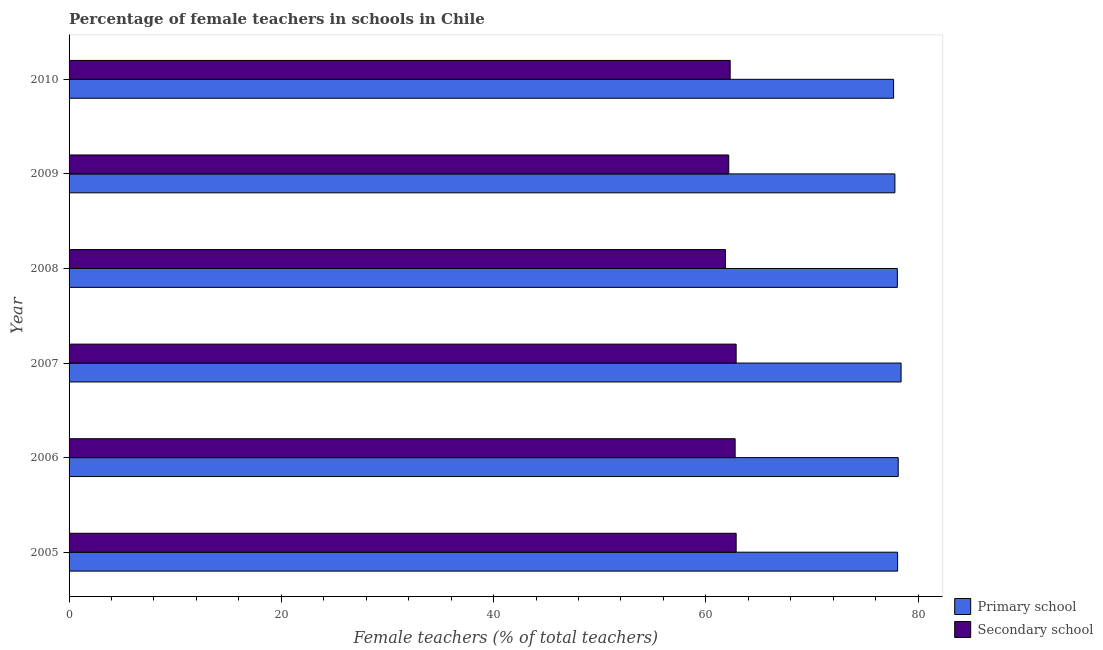How many different coloured bars are there?
Offer a terse response. 2. In how many cases, is the number of bars for a given year not equal to the number of legend labels?
Your answer should be compact. 0. What is the percentage of female teachers in primary schools in 2006?
Ensure brevity in your answer.  78.13. Across all years, what is the maximum percentage of female teachers in primary schools?
Offer a very short reply. 78.4. Across all years, what is the minimum percentage of female teachers in primary schools?
Give a very brief answer. 77.69. What is the total percentage of female teachers in secondary schools in the graph?
Offer a very short reply. 374.78. What is the difference between the percentage of female teachers in secondary schools in 2007 and that in 2009?
Keep it short and to the point. 0.7. What is the difference between the percentage of female teachers in primary schools in 2009 and the percentage of female teachers in secondary schools in 2006?
Offer a terse response. 15.05. What is the average percentage of female teachers in secondary schools per year?
Keep it short and to the point. 62.46. In the year 2007, what is the difference between the percentage of female teachers in secondary schools and percentage of female teachers in primary schools?
Make the answer very short. -15.54. In how many years, is the percentage of female teachers in secondary schools greater than 4 %?
Offer a very short reply. 6. Is the percentage of female teachers in secondary schools in 2005 less than that in 2009?
Provide a succinct answer. No. What is the difference between the highest and the second highest percentage of female teachers in primary schools?
Your answer should be compact. 0.27. What is the difference between the highest and the lowest percentage of female teachers in primary schools?
Ensure brevity in your answer.  0.71. In how many years, is the percentage of female teachers in primary schools greater than the average percentage of female teachers in primary schools taken over all years?
Offer a terse response. 4. Is the sum of the percentage of female teachers in secondary schools in 2005 and 2010 greater than the maximum percentage of female teachers in primary schools across all years?
Your response must be concise. Yes. What does the 1st bar from the top in 2010 represents?
Ensure brevity in your answer.  Secondary school. What does the 1st bar from the bottom in 2010 represents?
Your answer should be very brief. Primary school. Are all the bars in the graph horizontal?
Offer a terse response. Yes. Are the values on the major ticks of X-axis written in scientific E-notation?
Your answer should be very brief. No. Does the graph contain any zero values?
Keep it short and to the point. No. Where does the legend appear in the graph?
Provide a succinct answer. Bottom right. How many legend labels are there?
Your answer should be very brief. 2. How are the legend labels stacked?
Offer a terse response. Vertical. What is the title of the graph?
Your response must be concise. Percentage of female teachers in schools in Chile. Does "Primary school" appear as one of the legend labels in the graph?
Your answer should be very brief. Yes. What is the label or title of the X-axis?
Provide a succinct answer. Female teachers (% of total teachers). What is the label or title of the Y-axis?
Provide a short and direct response. Year. What is the Female teachers (% of total teachers) in Primary school in 2005?
Make the answer very short. 78.07. What is the Female teachers (% of total teachers) of Secondary school in 2005?
Your answer should be very brief. 62.86. What is the Female teachers (% of total teachers) in Primary school in 2006?
Give a very brief answer. 78.13. What is the Female teachers (% of total teachers) in Secondary school in 2006?
Provide a short and direct response. 62.76. What is the Female teachers (% of total teachers) of Primary school in 2007?
Provide a succinct answer. 78.4. What is the Female teachers (% of total teachers) in Secondary school in 2007?
Offer a very short reply. 62.86. What is the Female teachers (% of total teachers) in Primary school in 2008?
Provide a short and direct response. 78.05. What is the Female teachers (% of total teachers) in Secondary school in 2008?
Provide a short and direct response. 61.85. What is the Female teachers (% of total teachers) in Primary school in 2009?
Make the answer very short. 77.82. What is the Female teachers (% of total teachers) of Secondary school in 2009?
Your answer should be compact. 62.16. What is the Female teachers (% of total teachers) in Primary school in 2010?
Your answer should be compact. 77.69. What is the Female teachers (% of total teachers) of Secondary school in 2010?
Offer a terse response. 62.29. Across all years, what is the maximum Female teachers (% of total teachers) in Primary school?
Offer a very short reply. 78.4. Across all years, what is the maximum Female teachers (% of total teachers) in Secondary school?
Offer a terse response. 62.86. Across all years, what is the minimum Female teachers (% of total teachers) of Primary school?
Give a very brief answer. 77.69. Across all years, what is the minimum Female teachers (% of total teachers) in Secondary school?
Your answer should be very brief. 61.85. What is the total Female teachers (% of total teachers) of Primary school in the graph?
Give a very brief answer. 468.15. What is the total Female teachers (% of total teachers) in Secondary school in the graph?
Your response must be concise. 374.78. What is the difference between the Female teachers (% of total teachers) in Primary school in 2005 and that in 2006?
Provide a short and direct response. -0.06. What is the difference between the Female teachers (% of total teachers) of Secondary school in 2005 and that in 2006?
Provide a short and direct response. 0.1. What is the difference between the Female teachers (% of total teachers) in Primary school in 2005 and that in 2007?
Your answer should be very brief. -0.33. What is the difference between the Female teachers (% of total teachers) of Secondary school in 2005 and that in 2007?
Give a very brief answer. 0. What is the difference between the Female teachers (% of total teachers) in Primary school in 2005 and that in 2008?
Offer a very short reply. 0.02. What is the difference between the Female teachers (% of total teachers) of Secondary school in 2005 and that in 2008?
Your response must be concise. 1.01. What is the difference between the Female teachers (% of total teachers) of Primary school in 2005 and that in 2009?
Give a very brief answer. 0.25. What is the difference between the Female teachers (% of total teachers) in Secondary school in 2005 and that in 2009?
Your answer should be compact. 0.7. What is the difference between the Female teachers (% of total teachers) of Primary school in 2005 and that in 2010?
Give a very brief answer. 0.38. What is the difference between the Female teachers (% of total teachers) of Secondary school in 2005 and that in 2010?
Make the answer very short. 0.56. What is the difference between the Female teachers (% of total teachers) in Primary school in 2006 and that in 2007?
Provide a succinct answer. -0.27. What is the difference between the Female teachers (% of total teachers) of Secondary school in 2006 and that in 2007?
Your answer should be very brief. -0.09. What is the difference between the Female teachers (% of total teachers) in Primary school in 2006 and that in 2008?
Your response must be concise. 0.08. What is the difference between the Female teachers (% of total teachers) in Secondary school in 2006 and that in 2008?
Ensure brevity in your answer.  0.91. What is the difference between the Female teachers (% of total teachers) of Primary school in 2006 and that in 2009?
Offer a terse response. 0.31. What is the difference between the Female teachers (% of total teachers) of Secondary school in 2006 and that in 2009?
Make the answer very short. 0.6. What is the difference between the Female teachers (% of total teachers) in Primary school in 2006 and that in 2010?
Make the answer very short. 0.44. What is the difference between the Female teachers (% of total teachers) in Secondary school in 2006 and that in 2010?
Your answer should be compact. 0.47. What is the difference between the Female teachers (% of total teachers) in Primary school in 2007 and that in 2008?
Provide a succinct answer. 0.35. What is the difference between the Female teachers (% of total teachers) of Primary school in 2007 and that in 2009?
Ensure brevity in your answer.  0.58. What is the difference between the Female teachers (% of total teachers) in Secondary school in 2007 and that in 2009?
Your answer should be very brief. 0.7. What is the difference between the Female teachers (% of total teachers) in Primary school in 2007 and that in 2010?
Provide a succinct answer. 0.71. What is the difference between the Female teachers (% of total teachers) of Secondary school in 2007 and that in 2010?
Your answer should be compact. 0.56. What is the difference between the Female teachers (% of total teachers) of Primary school in 2008 and that in 2009?
Your response must be concise. 0.23. What is the difference between the Female teachers (% of total teachers) of Secondary school in 2008 and that in 2009?
Your answer should be compact. -0.31. What is the difference between the Female teachers (% of total teachers) of Primary school in 2008 and that in 2010?
Make the answer very short. 0.35. What is the difference between the Female teachers (% of total teachers) of Secondary school in 2008 and that in 2010?
Provide a succinct answer. -0.44. What is the difference between the Female teachers (% of total teachers) in Primary school in 2009 and that in 2010?
Offer a very short reply. 0.12. What is the difference between the Female teachers (% of total teachers) in Secondary school in 2009 and that in 2010?
Provide a short and direct response. -0.13. What is the difference between the Female teachers (% of total teachers) in Primary school in 2005 and the Female teachers (% of total teachers) in Secondary school in 2006?
Provide a succinct answer. 15.31. What is the difference between the Female teachers (% of total teachers) in Primary school in 2005 and the Female teachers (% of total teachers) in Secondary school in 2007?
Keep it short and to the point. 15.21. What is the difference between the Female teachers (% of total teachers) in Primary school in 2005 and the Female teachers (% of total teachers) in Secondary school in 2008?
Keep it short and to the point. 16.22. What is the difference between the Female teachers (% of total teachers) of Primary school in 2005 and the Female teachers (% of total teachers) of Secondary school in 2009?
Provide a succinct answer. 15.91. What is the difference between the Female teachers (% of total teachers) of Primary school in 2005 and the Female teachers (% of total teachers) of Secondary school in 2010?
Make the answer very short. 15.78. What is the difference between the Female teachers (% of total teachers) of Primary school in 2006 and the Female teachers (% of total teachers) of Secondary school in 2007?
Your answer should be compact. 15.27. What is the difference between the Female teachers (% of total teachers) of Primary school in 2006 and the Female teachers (% of total teachers) of Secondary school in 2008?
Your answer should be compact. 16.28. What is the difference between the Female teachers (% of total teachers) in Primary school in 2006 and the Female teachers (% of total teachers) in Secondary school in 2009?
Offer a very short reply. 15.97. What is the difference between the Female teachers (% of total teachers) of Primary school in 2006 and the Female teachers (% of total teachers) of Secondary school in 2010?
Offer a very short reply. 15.84. What is the difference between the Female teachers (% of total teachers) of Primary school in 2007 and the Female teachers (% of total teachers) of Secondary school in 2008?
Your answer should be compact. 16.55. What is the difference between the Female teachers (% of total teachers) of Primary school in 2007 and the Female teachers (% of total teachers) of Secondary school in 2009?
Your answer should be compact. 16.24. What is the difference between the Female teachers (% of total teachers) in Primary school in 2007 and the Female teachers (% of total teachers) in Secondary school in 2010?
Offer a very short reply. 16.1. What is the difference between the Female teachers (% of total teachers) of Primary school in 2008 and the Female teachers (% of total teachers) of Secondary school in 2009?
Provide a succinct answer. 15.89. What is the difference between the Female teachers (% of total teachers) of Primary school in 2008 and the Female teachers (% of total teachers) of Secondary school in 2010?
Provide a short and direct response. 15.75. What is the difference between the Female teachers (% of total teachers) in Primary school in 2009 and the Female teachers (% of total teachers) in Secondary school in 2010?
Provide a succinct answer. 15.52. What is the average Female teachers (% of total teachers) of Primary school per year?
Offer a terse response. 78.02. What is the average Female teachers (% of total teachers) in Secondary school per year?
Give a very brief answer. 62.46. In the year 2005, what is the difference between the Female teachers (% of total teachers) in Primary school and Female teachers (% of total teachers) in Secondary school?
Your response must be concise. 15.21. In the year 2006, what is the difference between the Female teachers (% of total teachers) in Primary school and Female teachers (% of total teachers) in Secondary school?
Provide a succinct answer. 15.37. In the year 2007, what is the difference between the Female teachers (% of total teachers) of Primary school and Female teachers (% of total teachers) of Secondary school?
Your answer should be compact. 15.54. In the year 2008, what is the difference between the Female teachers (% of total teachers) in Primary school and Female teachers (% of total teachers) in Secondary school?
Keep it short and to the point. 16.19. In the year 2009, what is the difference between the Female teachers (% of total teachers) in Primary school and Female teachers (% of total teachers) in Secondary school?
Keep it short and to the point. 15.66. In the year 2010, what is the difference between the Female teachers (% of total teachers) in Primary school and Female teachers (% of total teachers) in Secondary school?
Provide a short and direct response. 15.4. What is the ratio of the Female teachers (% of total teachers) of Primary school in 2005 to that in 2006?
Offer a very short reply. 1. What is the ratio of the Female teachers (% of total teachers) of Secondary school in 2005 to that in 2006?
Ensure brevity in your answer.  1. What is the ratio of the Female teachers (% of total teachers) in Primary school in 2005 to that in 2007?
Provide a short and direct response. 1. What is the ratio of the Female teachers (% of total teachers) of Secondary school in 2005 to that in 2007?
Your response must be concise. 1. What is the ratio of the Female teachers (% of total teachers) of Secondary school in 2005 to that in 2008?
Provide a short and direct response. 1.02. What is the ratio of the Female teachers (% of total teachers) in Primary school in 2005 to that in 2009?
Offer a terse response. 1. What is the ratio of the Female teachers (% of total teachers) of Secondary school in 2005 to that in 2009?
Your answer should be compact. 1.01. What is the ratio of the Female teachers (% of total teachers) of Secondary school in 2005 to that in 2010?
Provide a short and direct response. 1.01. What is the ratio of the Female teachers (% of total teachers) in Primary school in 2006 to that in 2007?
Your response must be concise. 1. What is the ratio of the Female teachers (% of total teachers) of Primary school in 2006 to that in 2008?
Offer a very short reply. 1. What is the ratio of the Female teachers (% of total teachers) of Secondary school in 2006 to that in 2008?
Provide a short and direct response. 1.01. What is the ratio of the Female teachers (% of total teachers) of Primary school in 2006 to that in 2009?
Keep it short and to the point. 1. What is the ratio of the Female teachers (% of total teachers) of Secondary school in 2006 to that in 2009?
Give a very brief answer. 1.01. What is the ratio of the Female teachers (% of total teachers) in Primary school in 2006 to that in 2010?
Keep it short and to the point. 1.01. What is the ratio of the Female teachers (% of total teachers) of Secondary school in 2006 to that in 2010?
Your response must be concise. 1.01. What is the ratio of the Female teachers (% of total teachers) in Secondary school in 2007 to that in 2008?
Offer a very short reply. 1.02. What is the ratio of the Female teachers (% of total teachers) of Primary school in 2007 to that in 2009?
Your answer should be very brief. 1.01. What is the ratio of the Female teachers (% of total teachers) in Secondary school in 2007 to that in 2009?
Provide a short and direct response. 1.01. What is the ratio of the Female teachers (% of total teachers) of Primary school in 2007 to that in 2010?
Keep it short and to the point. 1.01. What is the ratio of the Female teachers (% of total teachers) of Secondary school in 2007 to that in 2010?
Provide a short and direct response. 1.01. What is the ratio of the Female teachers (% of total teachers) in Secondary school in 2008 to that in 2009?
Offer a very short reply. 0.99. What is the ratio of the Female teachers (% of total teachers) in Secondary school in 2008 to that in 2010?
Give a very brief answer. 0.99. What is the ratio of the Female teachers (% of total teachers) in Primary school in 2009 to that in 2010?
Keep it short and to the point. 1. What is the difference between the highest and the second highest Female teachers (% of total teachers) in Primary school?
Offer a terse response. 0.27. What is the difference between the highest and the second highest Female teachers (% of total teachers) of Secondary school?
Make the answer very short. 0. What is the difference between the highest and the lowest Female teachers (% of total teachers) of Primary school?
Make the answer very short. 0.71. What is the difference between the highest and the lowest Female teachers (% of total teachers) of Secondary school?
Your response must be concise. 1.01. 